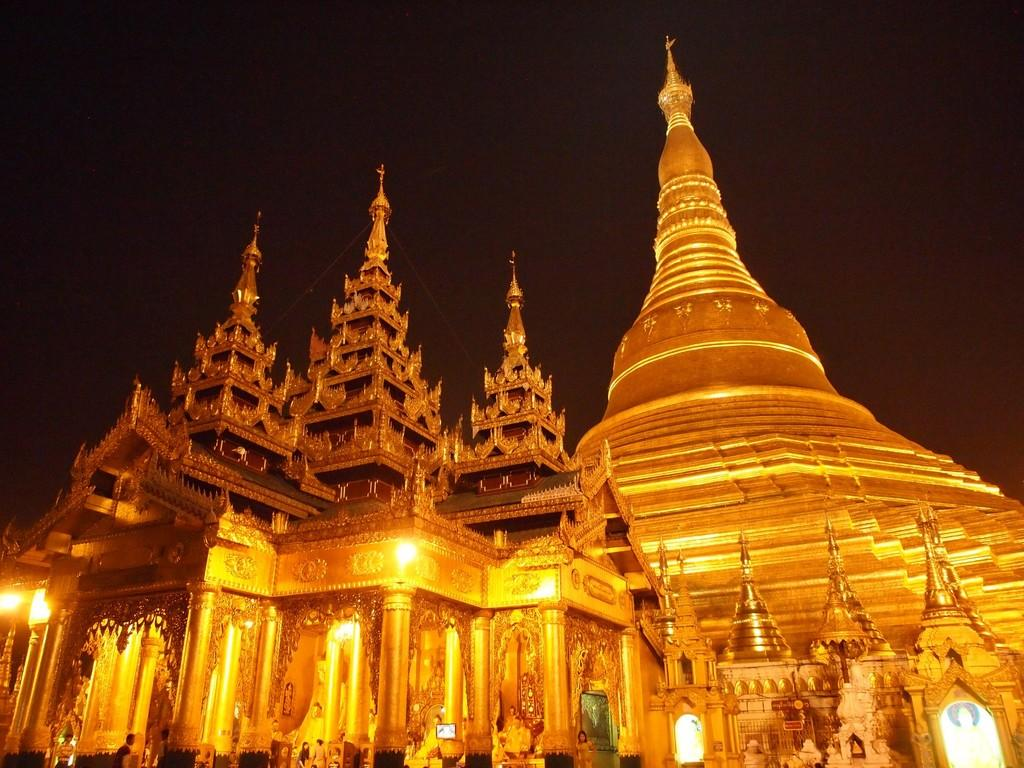What type of structure is in the image? There is a temple in the image. What features can be seen on the temple? The temple has sculptures, lights, and pillars. Are there any people in the image? Yes, there are people at the bottom of the image. What is the color of the background in the image? The background of the image is dark. What type of rock is being used to care for the copper in the image? There is no rock or copper present in the image; it features a temple with sculptures, lights, and pillars. 